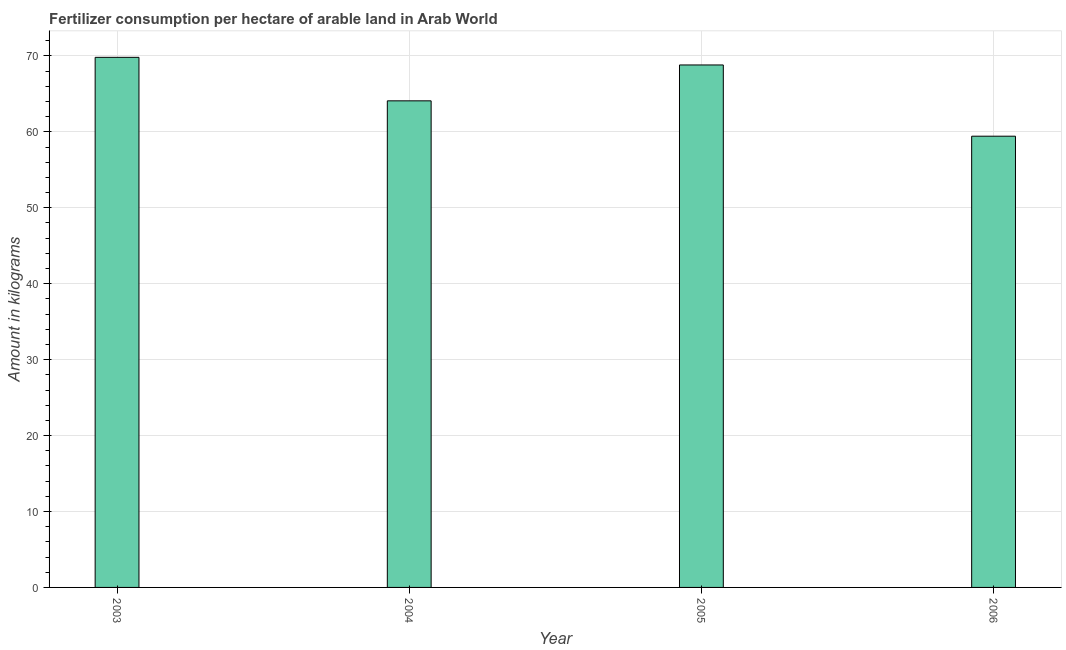Does the graph contain grids?
Keep it short and to the point. Yes. What is the title of the graph?
Your answer should be very brief. Fertilizer consumption per hectare of arable land in Arab World . What is the label or title of the X-axis?
Your answer should be compact. Year. What is the label or title of the Y-axis?
Give a very brief answer. Amount in kilograms. What is the amount of fertilizer consumption in 2003?
Give a very brief answer. 69.82. Across all years, what is the maximum amount of fertilizer consumption?
Provide a succinct answer. 69.82. Across all years, what is the minimum amount of fertilizer consumption?
Give a very brief answer. 59.43. In which year was the amount of fertilizer consumption minimum?
Your answer should be very brief. 2006. What is the sum of the amount of fertilizer consumption?
Your response must be concise. 262.15. What is the difference between the amount of fertilizer consumption in 2004 and 2006?
Your answer should be very brief. 4.66. What is the average amount of fertilizer consumption per year?
Make the answer very short. 65.54. What is the median amount of fertilizer consumption?
Make the answer very short. 66.45. What is the ratio of the amount of fertilizer consumption in 2004 to that in 2005?
Your answer should be very brief. 0.93. Is the amount of fertilizer consumption in 2004 less than that in 2005?
Give a very brief answer. Yes. Is the sum of the amount of fertilizer consumption in 2005 and 2006 greater than the maximum amount of fertilizer consumption across all years?
Give a very brief answer. Yes. What is the difference between the highest and the lowest amount of fertilizer consumption?
Keep it short and to the point. 10.39. In how many years, is the amount of fertilizer consumption greater than the average amount of fertilizer consumption taken over all years?
Give a very brief answer. 2. How many bars are there?
Your response must be concise. 4. How many years are there in the graph?
Ensure brevity in your answer.  4. Are the values on the major ticks of Y-axis written in scientific E-notation?
Offer a terse response. No. What is the Amount in kilograms of 2003?
Ensure brevity in your answer.  69.82. What is the Amount in kilograms of 2004?
Ensure brevity in your answer.  64.09. What is the Amount in kilograms in 2005?
Ensure brevity in your answer.  68.81. What is the Amount in kilograms of 2006?
Make the answer very short. 59.43. What is the difference between the Amount in kilograms in 2003 and 2004?
Your answer should be very brief. 5.73. What is the difference between the Amount in kilograms in 2003 and 2005?
Offer a terse response. 1. What is the difference between the Amount in kilograms in 2003 and 2006?
Ensure brevity in your answer.  10.39. What is the difference between the Amount in kilograms in 2004 and 2005?
Your answer should be compact. -4.73. What is the difference between the Amount in kilograms in 2004 and 2006?
Keep it short and to the point. 4.66. What is the difference between the Amount in kilograms in 2005 and 2006?
Your answer should be very brief. 9.38. What is the ratio of the Amount in kilograms in 2003 to that in 2004?
Give a very brief answer. 1.09. What is the ratio of the Amount in kilograms in 2003 to that in 2006?
Your answer should be compact. 1.18. What is the ratio of the Amount in kilograms in 2004 to that in 2006?
Provide a succinct answer. 1.08. What is the ratio of the Amount in kilograms in 2005 to that in 2006?
Provide a short and direct response. 1.16. 